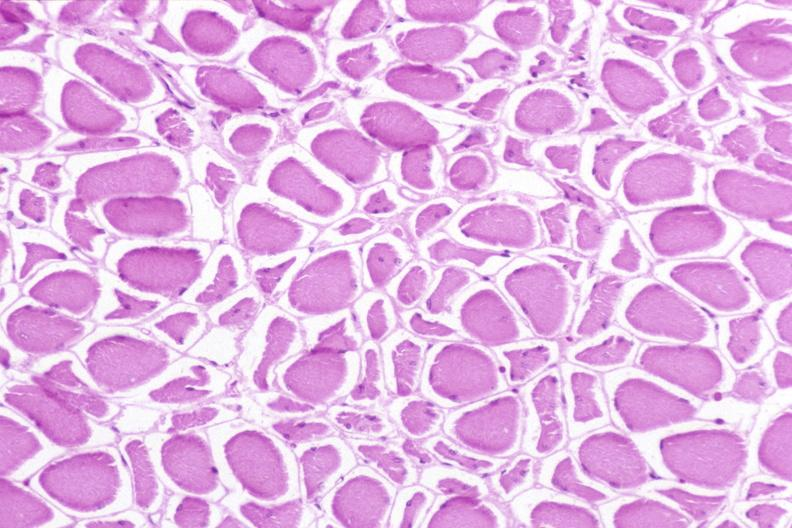what does this image show?
Answer the question using a single word or phrase. Skeletal muscle 